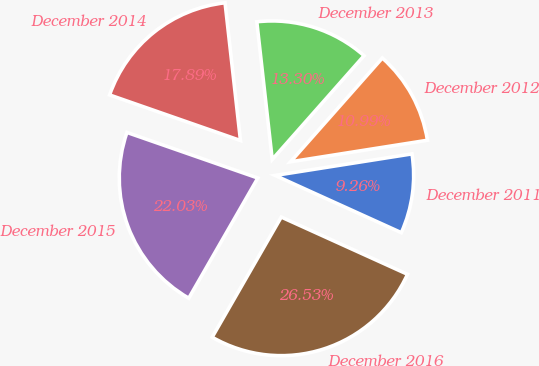Convert chart to OTSL. <chart><loc_0><loc_0><loc_500><loc_500><pie_chart><fcel>December 2011<fcel>December 2012<fcel>December 2013<fcel>December 2014<fcel>December 2015<fcel>December 2016<nl><fcel>9.26%<fcel>10.99%<fcel>13.3%<fcel>17.89%<fcel>22.03%<fcel>26.53%<nl></chart> 